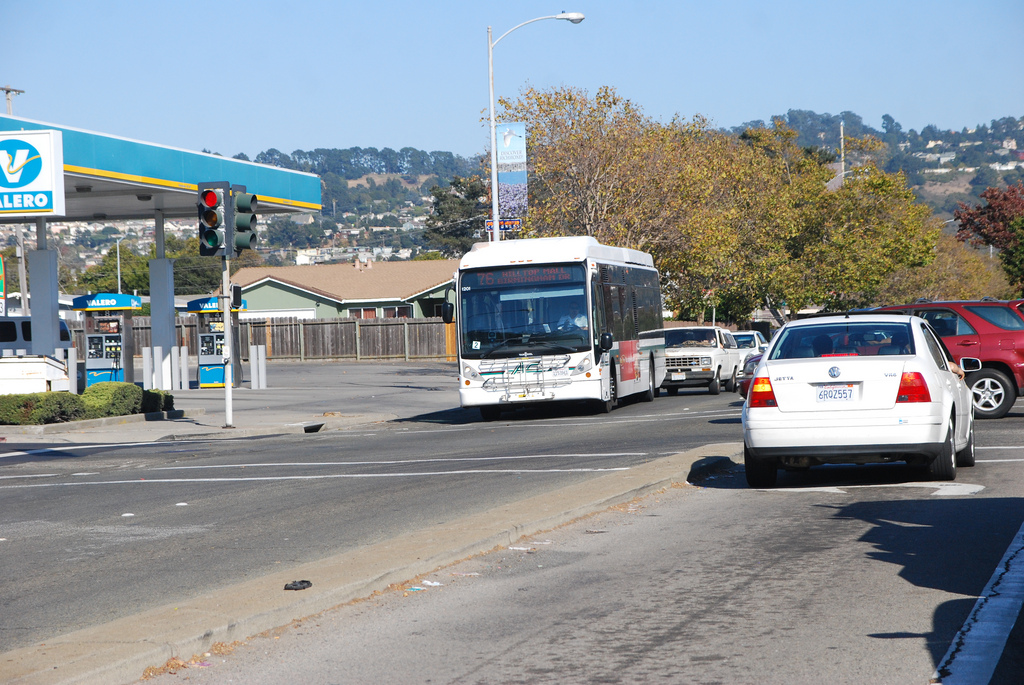Is the car to the left or to the right of the fence that is made of wood? The white car is positioned to the right of the wooden fence which borders the left edge of the image. 